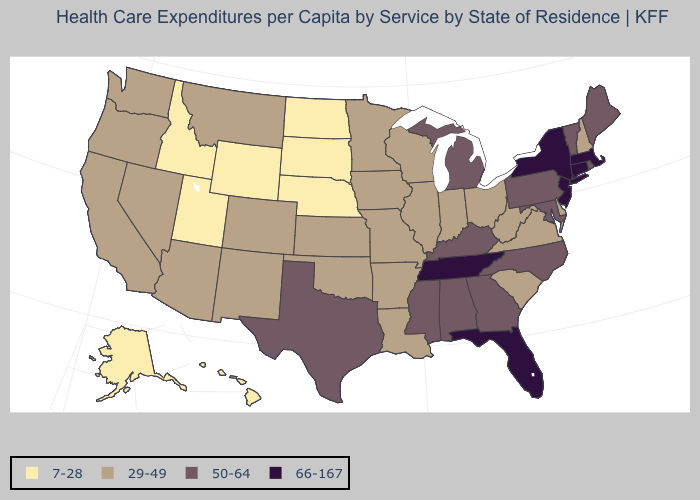What is the highest value in states that border Montana?
Give a very brief answer. 7-28. Does the map have missing data?
Quick response, please. No. Is the legend a continuous bar?
Concise answer only. No. Among the states that border Oregon , which have the lowest value?
Give a very brief answer. Idaho. What is the value of Michigan?
Be succinct. 50-64. What is the lowest value in the USA?
Keep it brief. 7-28. Name the states that have a value in the range 50-64?
Concise answer only. Alabama, Georgia, Kentucky, Maine, Maryland, Michigan, Mississippi, North Carolina, Pennsylvania, Rhode Island, Texas, Vermont. Does Minnesota have the same value as New York?
Quick response, please. No. Which states hav the highest value in the West?
Short answer required. Arizona, California, Colorado, Montana, Nevada, New Mexico, Oregon, Washington. Is the legend a continuous bar?
Short answer required. No. Name the states that have a value in the range 7-28?
Answer briefly. Alaska, Hawaii, Idaho, Nebraska, North Dakota, South Dakota, Utah, Wyoming. What is the highest value in states that border Delaware?
Answer briefly. 66-167. Is the legend a continuous bar?
Be succinct. No. What is the lowest value in the USA?
Keep it brief. 7-28. Among the states that border Minnesota , does Iowa have the lowest value?
Concise answer only. No. 